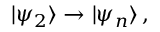Convert formula to latex. <formula><loc_0><loc_0><loc_500><loc_500>| \psi _ { 2 } \rangle \rightarrow | \psi _ { n } \rangle \, ,</formula> 